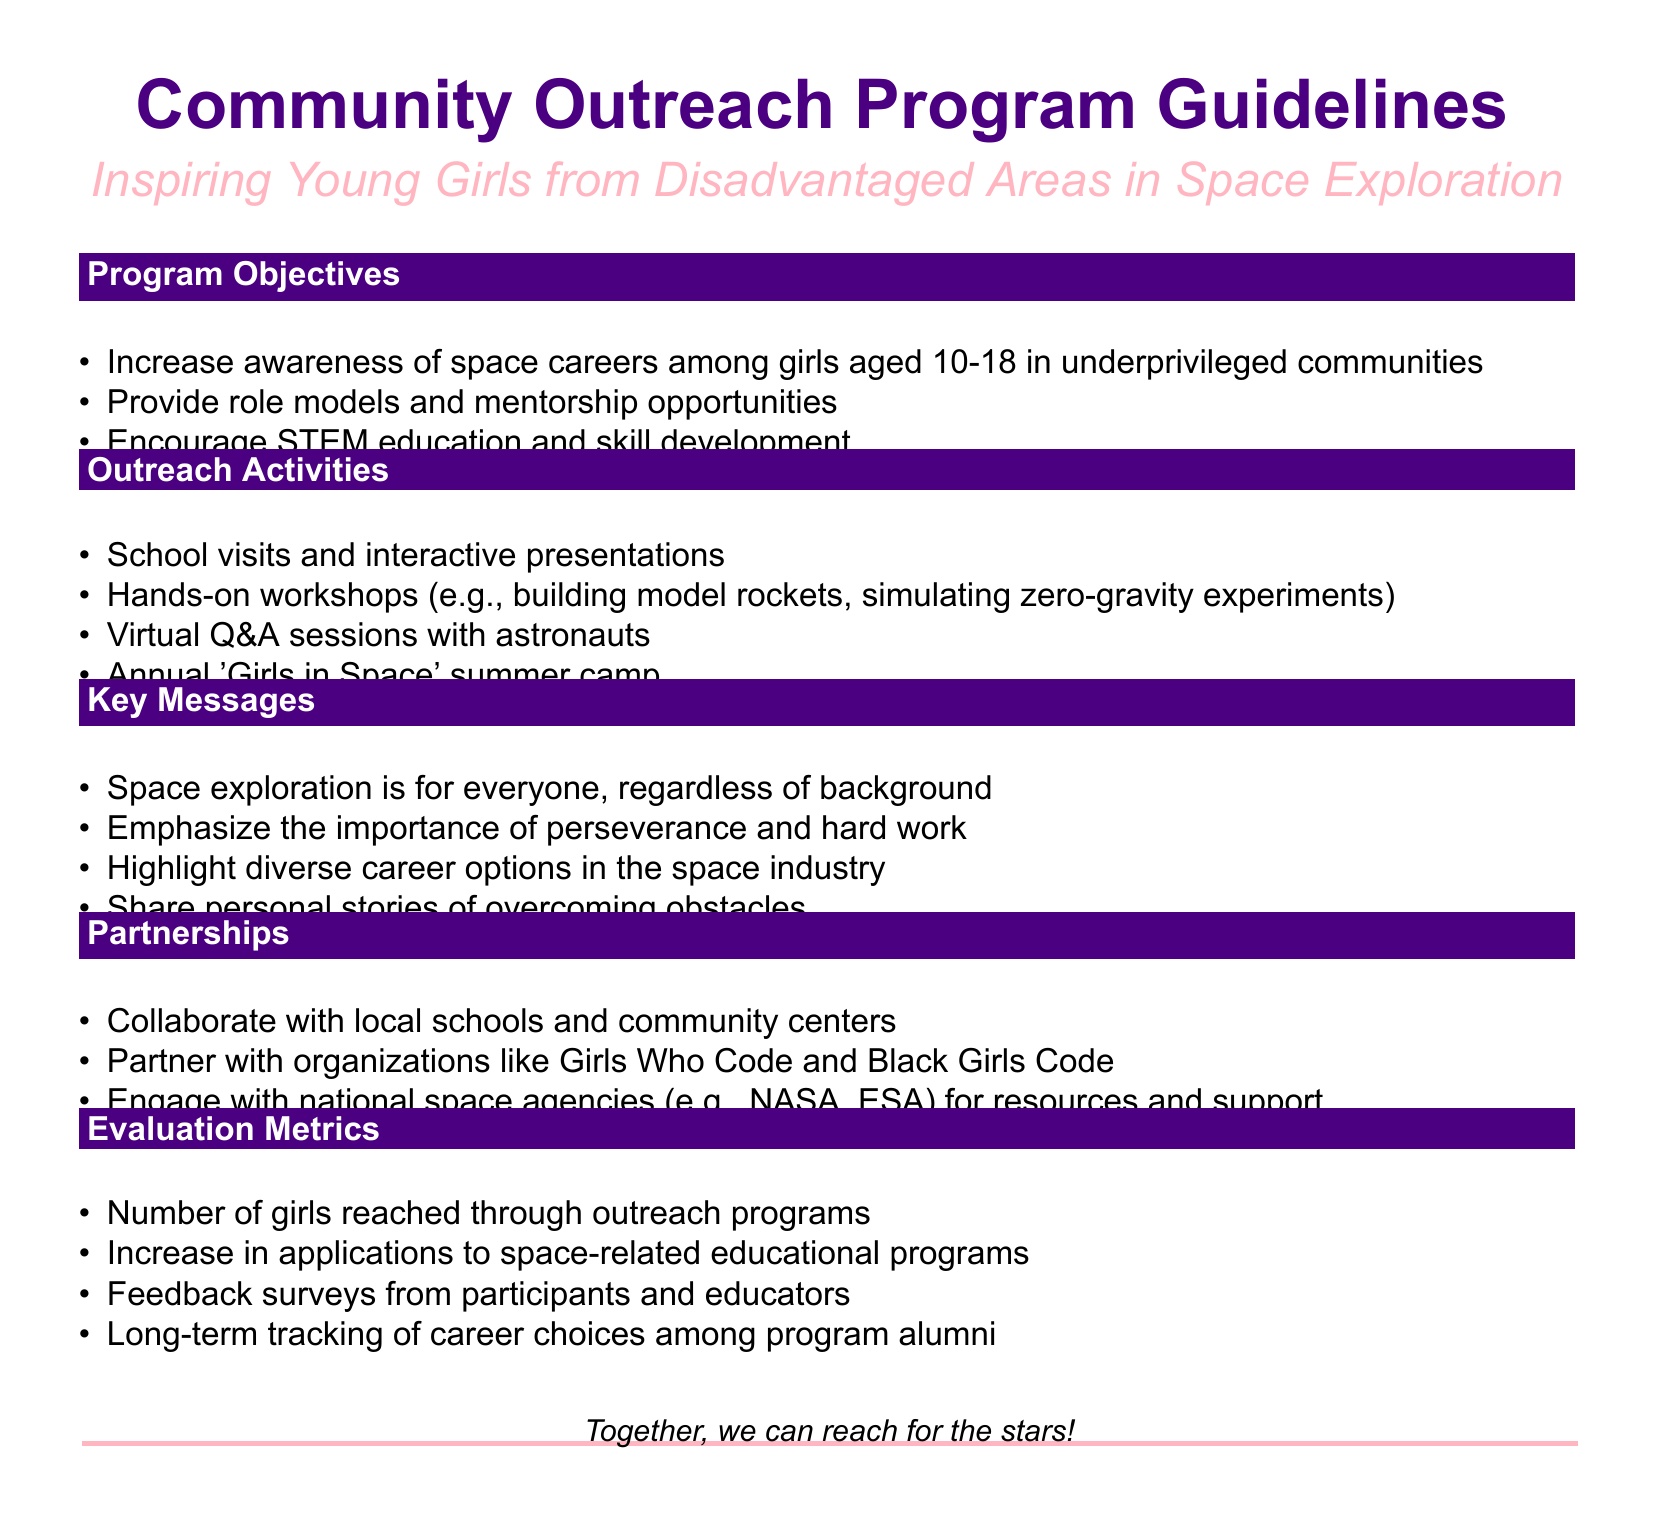What are the program objectives? The program objectives are outlined in the document, aiming to increase awareness and provide role models among girls in underprivileged communities.
Answer: Increase awareness of space careers among girls aged 10-18 in underprivileged communities What age group does the program target? The document specifies the age range targeted by the outreach program, which is girls aged 10 to 18.
Answer: 10-18 What specific activity is part of the outreach initiatives? The document lists several outreach activities designed to engage young girls, one of which is building model rockets.
Answer: Building model rockets Name a partner organization mentioned in the document. The document includes examples of organizations that the program will collaborate with, one of these is Girls Who Code.
Answer: Girls Who Code What is one evaluation metric listed in the document? The evaluation metrics section of the document provides ways to assess the program's success, such as feedback surveys from participants.
Answer: Feedback surveys from participants What is emphasized as a key message? The document highlights important messages to inspire young girls, one of which is that space exploration is for everyone.
Answer: Space exploration is for everyone How many outreach activities are listed in the document? The document provides a list of outreach activities, allowing us to count them to find the total.
Answer: 4 What event is mentioned that specifically targets girls in the program? The document mentions an annual event specifically designed for girls in the outreach program.
Answer: 'Girls in Space' summer camp 